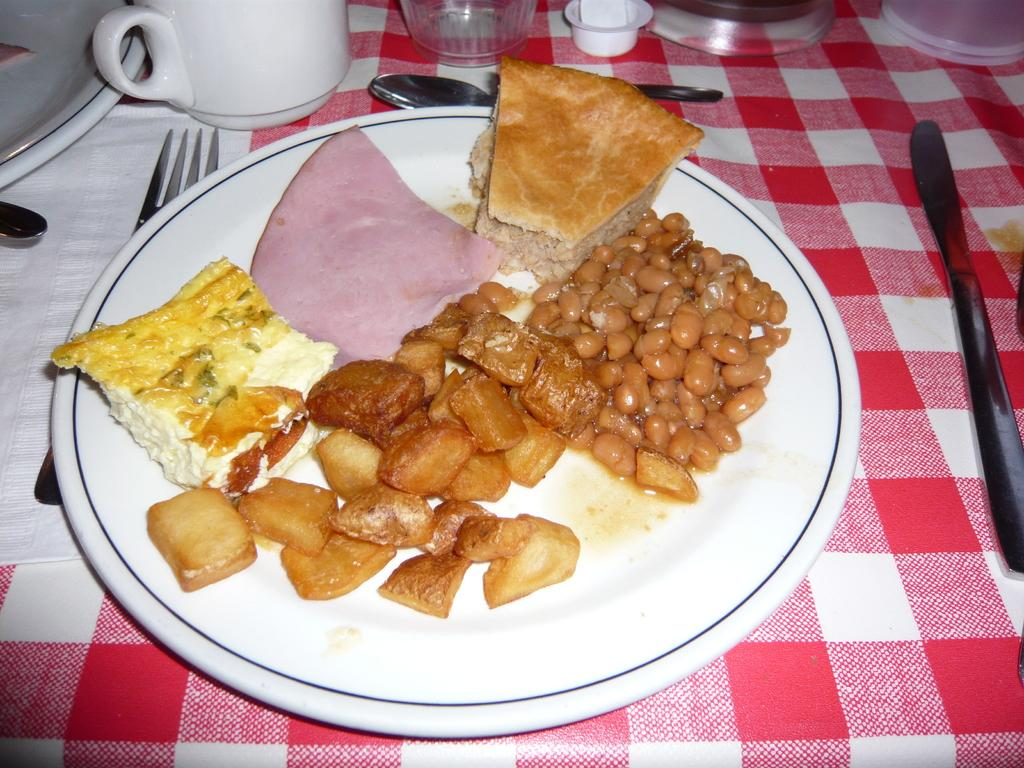What is on the plate in the image? There are food items on a white color plate in the image. What utensils are visible in the image? There is a fork and a spoon in the image. What is the cup used for in the image? The cup is likely used for holding a beverage. What else can be seen on the table in the image? There are other objects on the table in the image. How is the table decorated or covered in the image? The table is covered with a cloth. How many girls are walking on the trail in the image? There are no girls or trails present in the image; it features a table with food items, utensils, and other objects. 